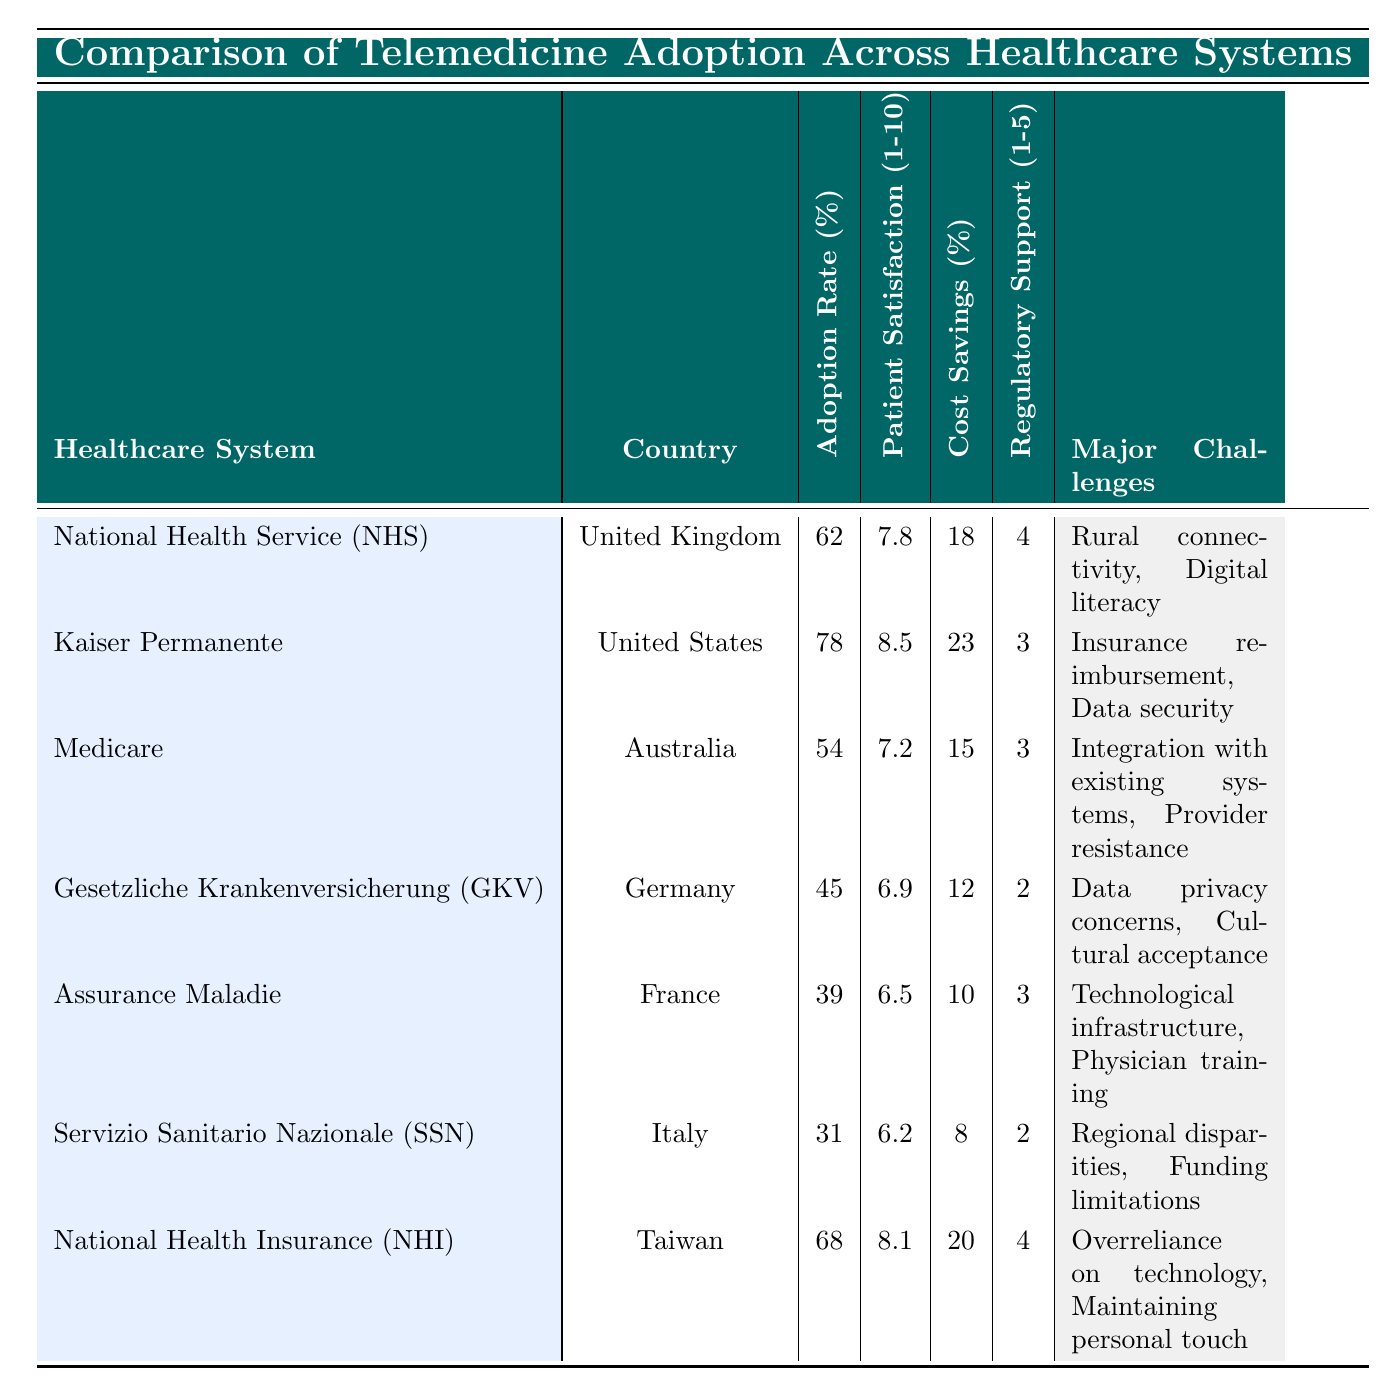What is the telemedicine adoption rate of the National Health Service (NHS) in the United Kingdom? The telemedicine adoption rate for the NHS, as stated in the table, is 62%. This information can be found directly under the "Telemedicine Adoption Rate (%)" column for the NHS row.
Answer: 62% Which healthcare system has the highest patient satisfaction score? To determine which healthcare system has the highest patient satisfaction score, we compare the scores listed in the "Patient Satisfaction Score (1-10)" column. Kaiser Permanente has the highest score of 8.5, which is greater than all the others listed.
Answer: Kaiser Permanente What is the average cost savings percentage across all healthcare systems? The cost savings percentages from the table are 18, 23, 15, 12, 10, 8, and 20. Summing these values gives 106. There are seven healthcare systems; thus, the average is calculated as 106/7, which equals approximately 15.14.
Answer: 15.14 Is the telemedicine adoption rate for mandatory health insurance systems generally higher than for voluntary systems? Based on the data, the telemedicine adoption rates for mandatory health insurance systems (NHS, NHS, and GKV) are 62%, 68%, and 45%, respectively, which averages to about 58.33%. In contrast, voluntary systems (Kaiser Permanente, Medicare, Assurance Maladie, and SSN) show lower adoption rates. Therefore, it can be inferred that mandatory systems tend to have higher rates.
Answer: Yes Which healthcare system has the lowest regulatory support score, and what are its major challenges? Looking at the "Regulatory Support (1-5)" column, the system with the lowest score is Gesetzliche Krankenversicherung (GKV) with a score of 2. The major challenges noted include "Data privacy concerns" and "Cultural acceptance."
Answer: Gesetzliche Krankenversicherung (GKV) and its challenges are data privacy concerns, cultural acceptance What is the difference in patient satisfaction scores between the highest and lowest systems? The highest patient satisfaction score is from Kaiser Permanente at 8.5, and the lowest is from Servizio Sanitario Nazionale (SSN) at 6.2. The difference is calculated as 8.5 - 6.2 = 2.3.
Answer: 2.3 Is telemedicine adoption in Germany higher than in France? The telemedicine adoption rate for Germany (GKV) is 45%, while for France (Assurance Maladie), it is 39%. Since 45% is greater than 39%, the statement is true.
Answer: Yes How many healthcare systems reported a telemedicine adoption rate above 60%? Examining the "Telemedicine Adoption Rate (%)" column, the systems with rates above 60% are NHS (62%), Kaiser Permanente (78%), and NHI (68%). This gives a total of three systems.
Answer: 3 